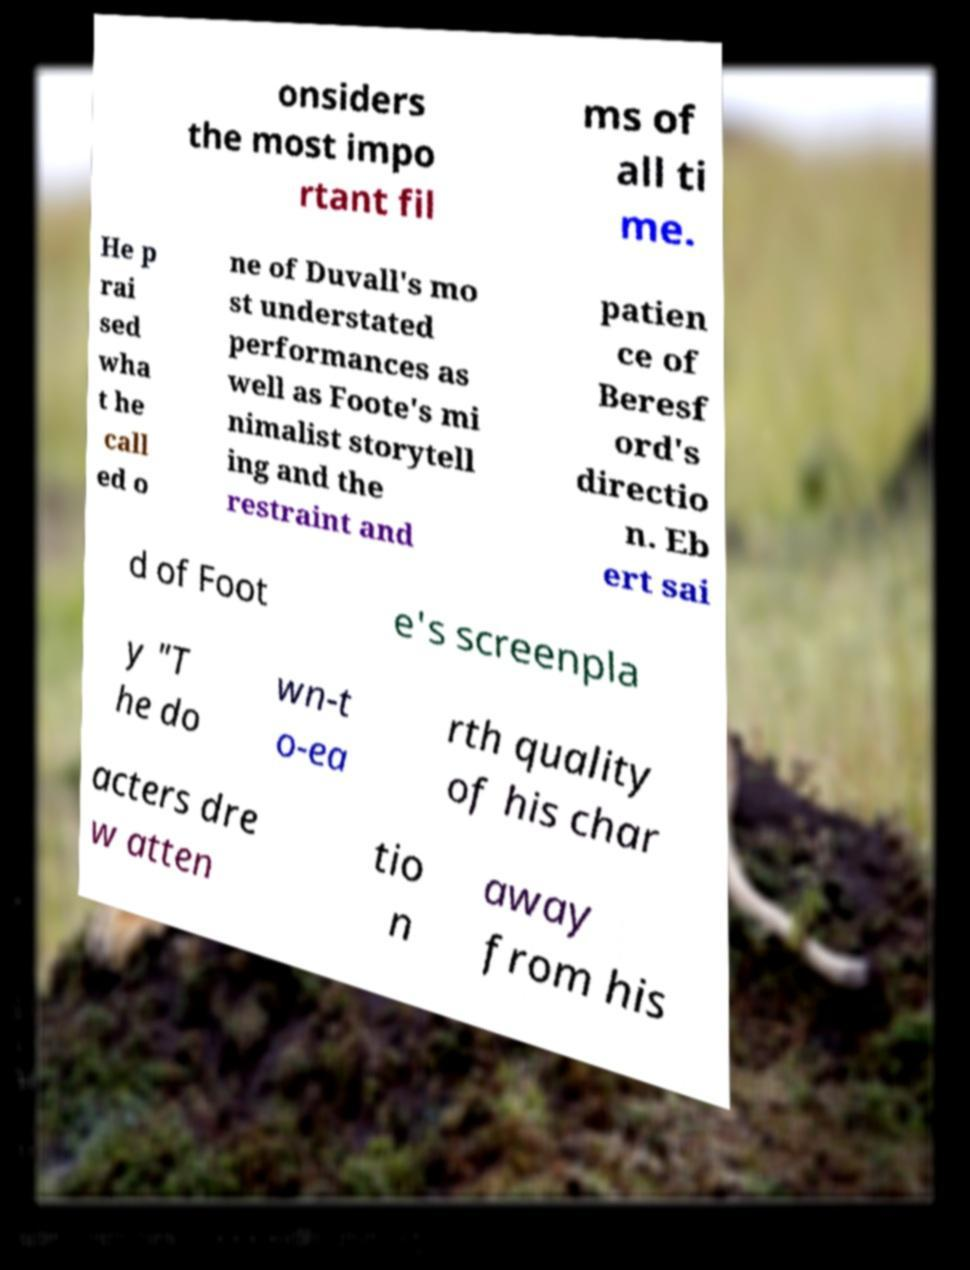Please read and relay the text visible in this image. What does it say? onsiders the most impo rtant fil ms of all ti me. He p rai sed wha t he call ed o ne of Duvall's mo st understated performances as well as Foote's mi nimalist storytell ing and the restraint and patien ce of Beresf ord's directio n. Eb ert sai d of Foot e's screenpla y "T he do wn-t o-ea rth quality of his char acters dre w atten tio n away from his 